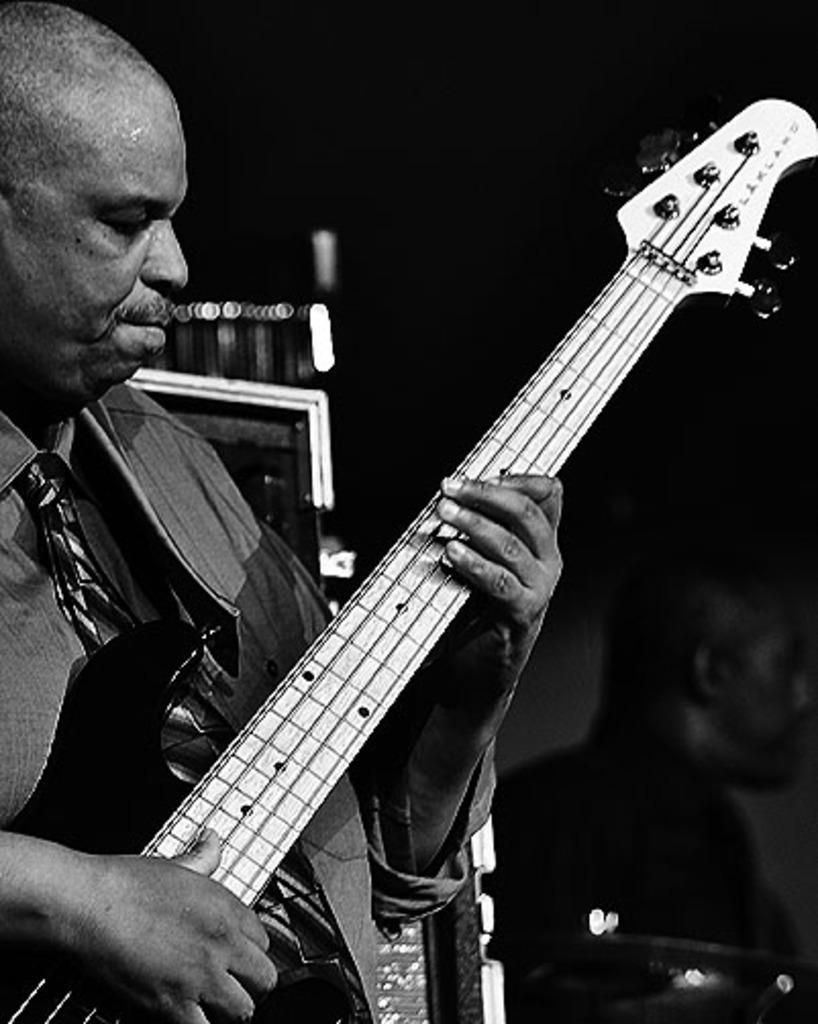Describe this image in one or two sentences. He is standing. He is playing a guitar. On the right side of the person is sitting on a chair. We can see in the background musical instruments. 